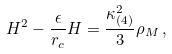<formula> <loc_0><loc_0><loc_500><loc_500>H ^ { 2 } - \frac { \epsilon } { r _ { c } } H = \frac { \kappa _ { ( 4 ) } ^ { 2 } } { 3 } \rho _ { M } \, ,</formula> 